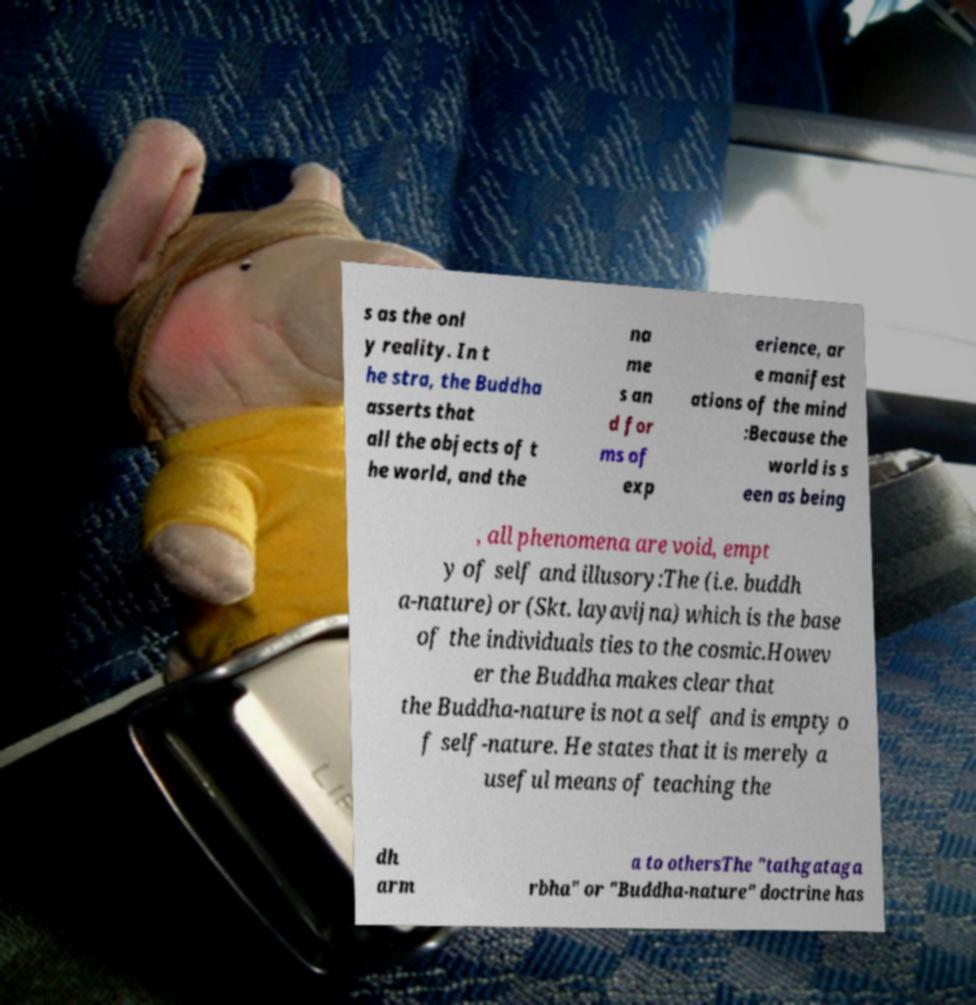Please identify and transcribe the text found in this image. s as the onl y reality. In t he stra, the Buddha asserts that all the objects of t he world, and the na me s an d for ms of exp erience, ar e manifest ations of the mind :Because the world is s een as being , all phenomena are void, empt y of self and illusory:The (i.e. buddh a-nature) or (Skt. layavijna) which is the base of the individuals ties to the cosmic.Howev er the Buddha makes clear that the Buddha-nature is not a self and is empty o f self-nature. He states that it is merely a useful means of teaching the dh arm a to othersThe "tathgataga rbha" or "Buddha-nature" doctrine has 